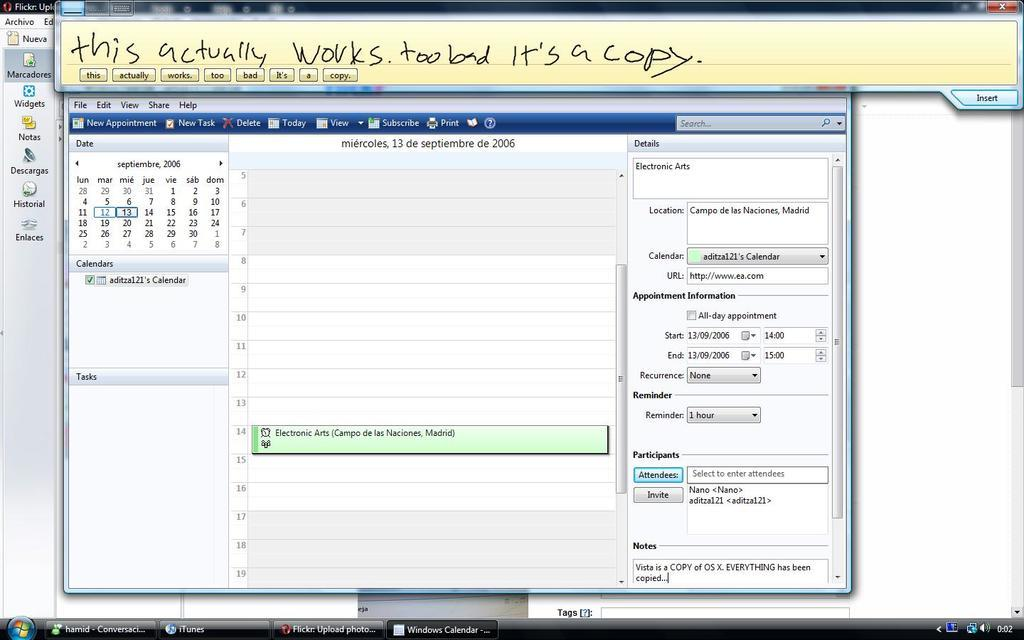<image>
Provide a brief description of the given image. A screen has too bad its a copy at the top 